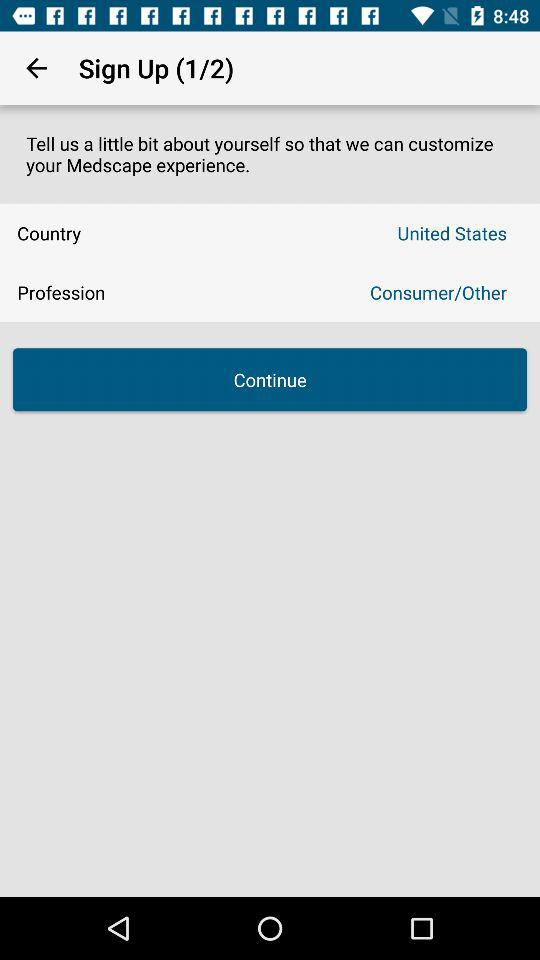What's the profession? The profession is consumer or other. 